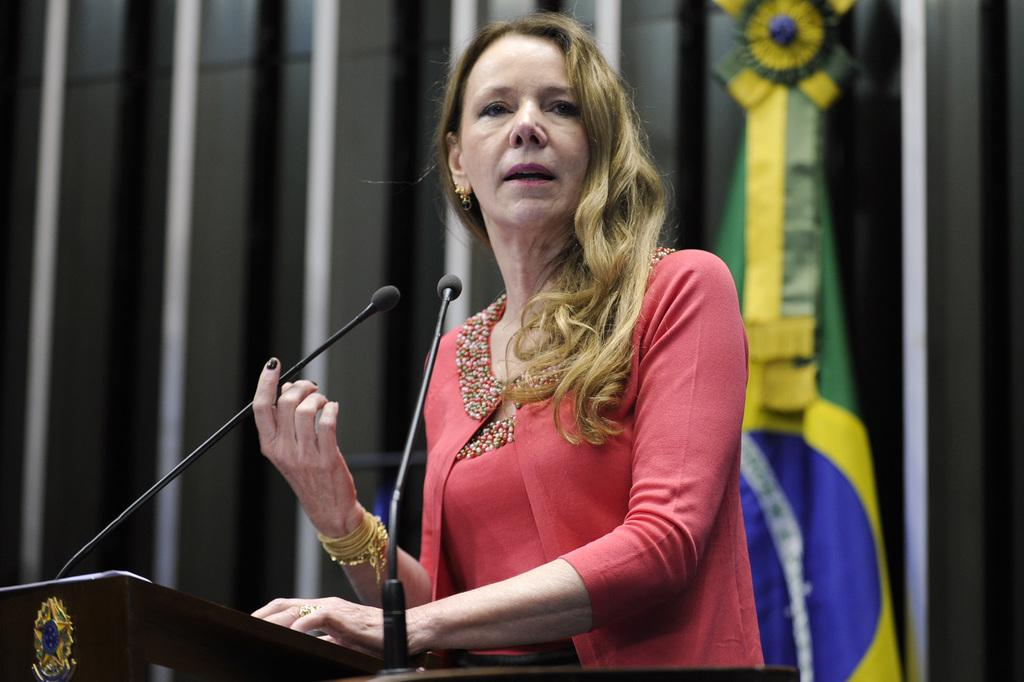What is the main subject of the image? There is a woman standing in the image. What object is visible near the woman? There is a microphone in the image. What can be seen in the background of the image? There is a flag in the background of the image. How many lamps are present on the dock in the image? There is no dock or lamp present in the image. What day of the week is it in the image? The day of the week cannot be determined from the image. 